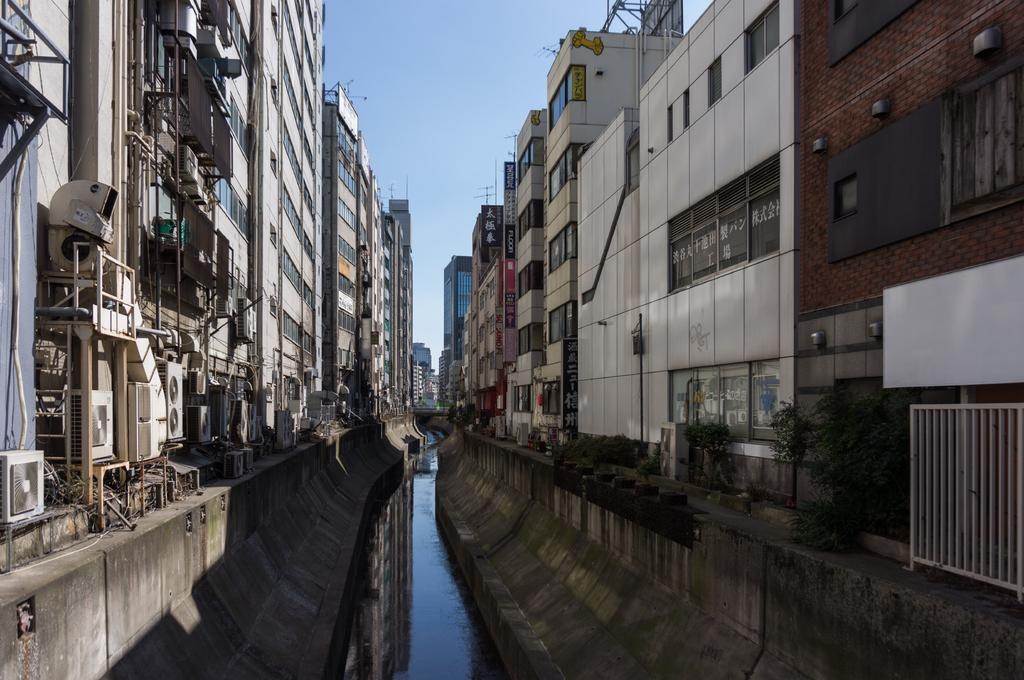What can be seen on both sides of the image? There are buildings on both sides of the image. What is located in the center of the image? There is water in the center of the image. What is visible at the top of the image? The sky is visible at the top of the image. Can you hear the box being carried by the porter in the image? There is no box or porter present in the image, so it is not possible to hear any related activity. 